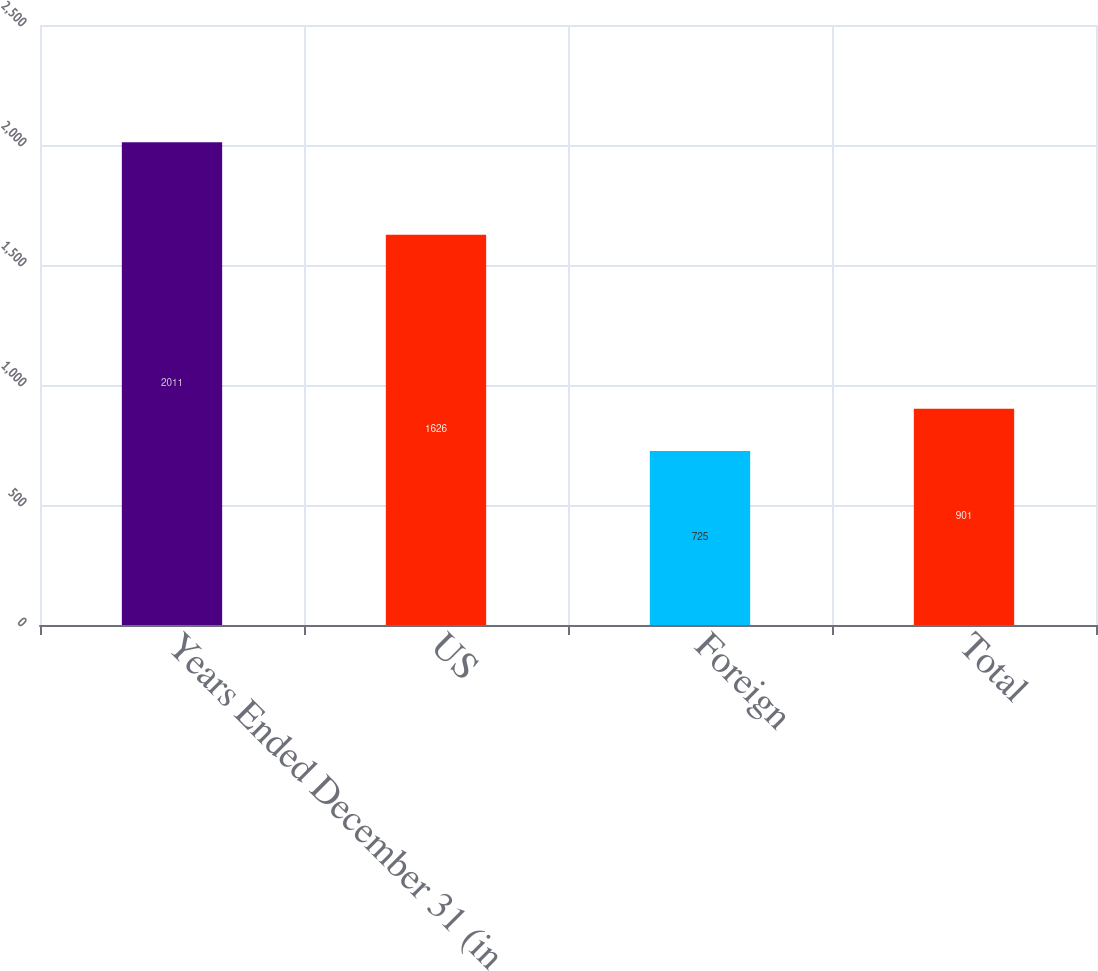Convert chart. <chart><loc_0><loc_0><loc_500><loc_500><bar_chart><fcel>Years Ended December 31 (in<fcel>US<fcel>Foreign<fcel>Total<nl><fcel>2011<fcel>1626<fcel>725<fcel>901<nl></chart> 